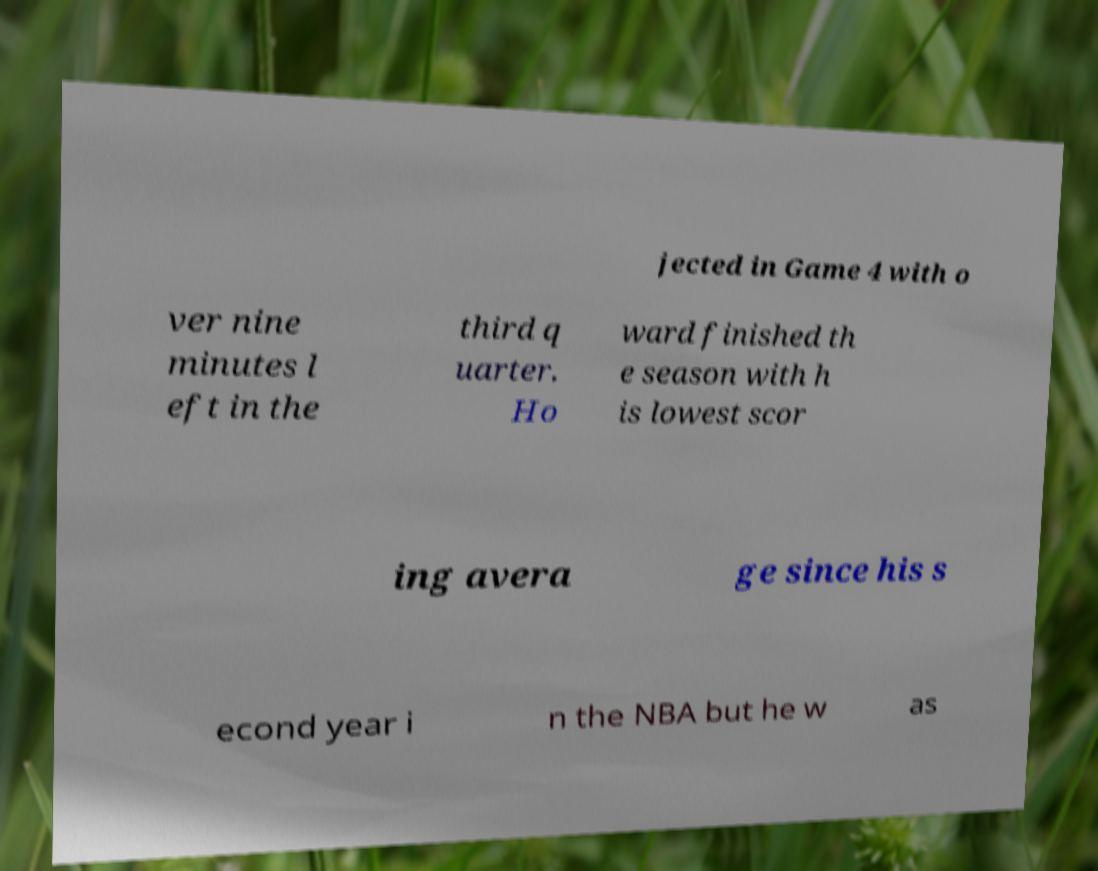There's text embedded in this image that I need extracted. Can you transcribe it verbatim? jected in Game 4 with o ver nine minutes l eft in the third q uarter. Ho ward finished th e season with h is lowest scor ing avera ge since his s econd year i n the NBA but he w as 